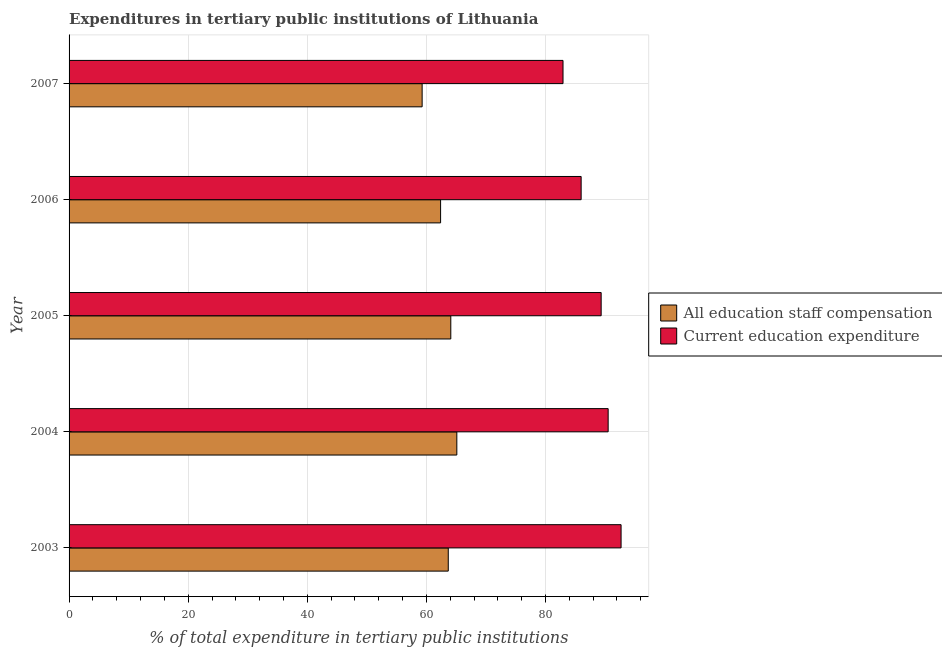How many different coloured bars are there?
Offer a terse response. 2. Are the number of bars per tick equal to the number of legend labels?
Your response must be concise. Yes. Are the number of bars on each tick of the Y-axis equal?
Your response must be concise. Yes. What is the label of the 4th group of bars from the top?
Your response must be concise. 2004. What is the expenditure in staff compensation in 2004?
Your answer should be compact. 65.11. Across all years, what is the maximum expenditure in staff compensation?
Provide a succinct answer. 65.11. Across all years, what is the minimum expenditure in staff compensation?
Keep it short and to the point. 59.29. In which year was the expenditure in staff compensation minimum?
Provide a succinct answer. 2007. What is the total expenditure in education in the graph?
Offer a very short reply. 441.48. What is the difference between the expenditure in staff compensation in 2004 and that in 2006?
Offer a terse response. 2.73. What is the difference between the expenditure in staff compensation in 2004 and the expenditure in education in 2005?
Your answer should be compact. -24.24. What is the average expenditure in staff compensation per year?
Give a very brief answer. 62.91. In the year 2007, what is the difference between the expenditure in education and expenditure in staff compensation?
Keep it short and to the point. 23.66. Is the expenditure in staff compensation in 2003 less than that in 2006?
Provide a short and direct response. No. Is the difference between the expenditure in education in 2003 and 2006 greater than the difference between the expenditure in staff compensation in 2003 and 2006?
Your response must be concise. Yes. What is the difference between the highest and the lowest expenditure in staff compensation?
Your answer should be compact. 5.82. What does the 1st bar from the top in 2006 represents?
Your answer should be compact. Current education expenditure. What does the 2nd bar from the bottom in 2006 represents?
Give a very brief answer. Current education expenditure. How many bars are there?
Your answer should be compact. 10. Does the graph contain grids?
Your answer should be compact. Yes. What is the title of the graph?
Give a very brief answer. Expenditures in tertiary public institutions of Lithuania. Does "International Tourists" appear as one of the legend labels in the graph?
Offer a terse response. No. What is the label or title of the X-axis?
Provide a short and direct response. % of total expenditure in tertiary public institutions. What is the label or title of the Y-axis?
Your answer should be compact. Year. What is the % of total expenditure in tertiary public institutions in All education staff compensation in 2003?
Your answer should be very brief. 63.67. What is the % of total expenditure in tertiary public institutions of Current education expenditure in 2003?
Give a very brief answer. 92.69. What is the % of total expenditure in tertiary public institutions of All education staff compensation in 2004?
Give a very brief answer. 65.11. What is the % of total expenditure in tertiary public institutions of Current education expenditure in 2004?
Provide a succinct answer. 90.52. What is the % of total expenditure in tertiary public institutions of All education staff compensation in 2005?
Provide a succinct answer. 64.1. What is the % of total expenditure in tertiary public institutions of Current education expenditure in 2005?
Offer a terse response. 89.35. What is the % of total expenditure in tertiary public institutions in All education staff compensation in 2006?
Ensure brevity in your answer.  62.38. What is the % of total expenditure in tertiary public institutions of Current education expenditure in 2006?
Provide a succinct answer. 85.98. What is the % of total expenditure in tertiary public institutions in All education staff compensation in 2007?
Make the answer very short. 59.29. What is the % of total expenditure in tertiary public institutions in Current education expenditure in 2007?
Your answer should be very brief. 82.94. Across all years, what is the maximum % of total expenditure in tertiary public institutions of All education staff compensation?
Ensure brevity in your answer.  65.11. Across all years, what is the maximum % of total expenditure in tertiary public institutions in Current education expenditure?
Provide a succinct answer. 92.69. Across all years, what is the minimum % of total expenditure in tertiary public institutions in All education staff compensation?
Offer a very short reply. 59.29. Across all years, what is the minimum % of total expenditure in tertiary public institutions of Current education expenditure?
Your answer should be compact. 82.94. What is the total % of total expenditure in tertiary public institutions of All education staff compensation in the graph?
Offer a terse response. 314.55. What is the total % of total expenditure in tertiary public institutions of Current education expenditure in the graph?
Your response must be concise. 441.49. What is the difference between the % of total expenditure in tertiary public institutions in All education staff compensation in 2003 and that in 2004?
Provide a succinct answer. -1.44. What is the difference between the % of total expenditure in tertiary public institutions of Current education expenditure in 2003 and that in 2004?
Provide a short and direct response. 2.17. What is the difference between the % of total expenditure in tertiary public institutions of All education staff compensation in 2003 and that in 2005?
Offer a very short reply. -0.43. What is the difference between the % of total expenditure in tertiary public institutions in Current education expenditure in 2003 and that in 2005?
Your answer should be very brief. 3.34. What is the difference between the % of total expenditure in tertiary public institutions of All education staff compensation in 2003 and that in 2006?
Offer a terse response. 1.29. What is the difference between the % of total expenditure in tertiary public institutions of Current education expenditure in 2003 and that in 2006?
Give a very brief answer. 6.71. What is the difference between the % of total expenditure in tertiary public institutions of All education staff compensation in 2003 and that in 2007?
Offer a terse response. 4.39. What is the difference between the % of total expenditure in tertiary public institutions of Current education expenditure in 2003 and that in 2007?
Offer a very short reply. 9.75. What is the difference between the % of total expenditure in tertiary public institutions in All education staff compensation in 2004 and that in 2005?
Ensure brevity in your answer.  1.01. What is the difference between the % of total expenditure in tertiary public institutions of Current education expenditure in 2004 and that in 2005?
Give a very brief answer. 1.17. What is the difference between the % of total expenditure in tertiary public institutions of All education staff compensation in 2004 and that in 2006?
Make the answer very short. 2.73. What is the difference between the % of total expenditure in tertiary public institutions in Current education expenditure in 2004 and that in 2006?
Give a very brief answer. 4.54. What is the difference between the % of total expenditure in tertiary public institutions of All education staff compensation in 2004 and that in 2007?
Provide a succinct answer. 5.82. What is the difference between the % of total expenditure in tertiary public institutions of Current education expenditure in 2004 and that in 2007?
Provide a short and direct response. 7.58. What is the difference between the % of total expenditure in tertiary public institutions of All education staff compensation in 2005 and that in 2006?
Provide a short and direct response. 1.71. What is the difference between the % of total expenditure in tertiary public institutions in Current education expenditure in 2005 and that in 2006?
Make the answer very short. 3.36. What is the difference between the % of total expenditure in tertiary public institutions in All education staff compensation in 2005 and that in 2007?
Keep it short and to the point. 4.81. What is the difference between the % of total expenditure in tertiary public institutions of Current education expenditure in 2005 and that in 2007?
Keep it short and to the point. 6.41. What is the difference between the % of total expenditure in tertiary public institutions in All education staff compensation in 2006 and that in 2007?
Make the answer very short. 3.1. What is the difference between the % of total expenditure in tertiary public institutions of Current education expenditure in 2006 and that in 2007?
Your answer should be compact. 3.04. What is the difference between the % of total expenditure in tertiary public institutions in All education staff compensation in 2003 and the % of total expenditure in tertiary public institutions in Current education expenditure in 2004?
Your answer should be very brief. -26.85. What is the difference between the % of total expenditure in tertiary public institutions of All education staff compensation in 2003 and the % of total expenditure in tertiary public institutions of Current education expenditure in 2005?
Provide a short and direct response. -25.67. What is the difference between the % of total expenditure in tertiary public institutions of All education staff compensation in 2003 and the % of total expenditure in tertiary public institutions of Current education expenditure in 2006?
Provide a short and direct response. -22.31. What is the difference between the % of total expenditure in tertiary public institutions of All education staff compensation in 2003 and the % of total expenditure in tertiary public institutions of Current education expenditure in 2007?
Ensure brevity in your answer.  -19.27. What is the difference between the % of total expenditure in tertiary public institutions in All education staff compensation in 2004 and the % of total expenditure in tertiary public institutions in Current education expenditure in 2005?
Your response must be concise. -24.24. What is the difference between the % of total expenditure in tertiary public institutions of All education staff compensation in 2004 and the % of total expenditure in tertiary public institutions of Current education expenditure in 2006?
Ensure brevity in your answer.  -20.87. What is the difference between the % of total expenditure in tertiary public institutions in All education staff compensation in 2004 and the % of total expenditure in tertiary public institutions in Current education expenditure in 2007?
Offer a terse response. -17.83. What is the difference between the % of total expenditure in tertiary public institutions of All education staff compensation in 2005 and the % of total expenditure in tertiary public institutions of Current education expenditure in 2006?
Provide a succinct answer. -21.89. What is the difference between the % of total expenditure in tertiary public institutions in All education staff compensation in 2005 and the % of total expenditure in tertiary public institutions in Current education expenditure in 2007?
Ensure brevity in your answer.  -18.84. What is the difference between the % of total expenditure in tertiary public institutions in All education staff compensation in 2006 and the % of total expenditure in tertiary public institutions in Current education expenditure in 2007?
Make the answer very short. -20.56. What is the average % of total expenditure in tertiary public institutions of All education staff compensation per year?
Offer a very short reply. 62.91. What is the average % of total expenditure in tertiary public institutions of Current education expenditure per year?
Your answer should be compact. 88.3. In the year 2003, what is the difference between the % of total expenditure in tertiary public institutions in All education staff compensation and % of total expenditure in tertiary public institutions in Current education expenditure?
Give a very brief answer. -29.02. In the year 2004, what is the difference between the % of total expenditure in tertiary public institutions in All education staff compensation and % of total expenditure in tertiary public institutions in Current education expenditure?
Offer a terse response. -25.41. In the year 2005, what is the difference between the % of total expenditure in tertiary public institutions in All education staff compensation and % of total expenditure in tertiary public institutions in Current education expenditure?
Ensure brevity in your answer.  -25.25. In the year 2006, what is the difference between the % of total expenditure in tertiary public institutions of All education staff compensation and % of total expenditure in tertiary public institutions of Current education expenditure?
Ensure brevity in your answer.  -23.6. In the year 2007, what is the difference between the % of total expenditure in tertiary public institutions of All education staff compensation and % of total expenditure in tertiary public institutions of Current education expenditure?
Your response must be concise. -23.66. What is the ratio of the % of total expenditure in tertiary public institutions in All education staff compensation in 2003 to that in 2004?
Your answer should be very brief. 0.98. What is the ratio of the % of total expenditure in tertiary public institutions of Current education expenditure in 2003 to that in 2004?
Keep it short and to the point. 1.02. What is the ratio of the % of total expenditure in tertiary public institutions of All education staff compensation in 2003 to that in 2005?
Ensure brevity in your answer.  0.99. What is the ratio of the % of total expenditure in tertiary public institutions in Current education expenditure in 2003 to that in 2005?
Offer a very short reply. 1.04. What is the ratio of the % of total expenditure in tertiary public institutions of All education staff compensation in 2003 to that in 2006?
Keep it short and to the point. 1.02. What is the ratio of the % of total expenditure in tertiary public institutions of Current education expenditure in 2003 to that in 2006?
Ensure brevity in your answer.  1.08. What is the ratio of the % of total expenditure in tertiary public institutions in All education staff compensation in 2003 to that in 2007?
Your answer should be compact. 1.07. What is the ratio of the % of total expenditure in tertiary public institutions of Current education expenditure in 2003 to that in 2007?
Provide a short and direct response. 1.12. What is the ratio of the % of total expenditure in tertiary public institutions in All education staff compensation in 2004 to that in 2005?
Provide a short and direct response. 1.02. What is the ratio of the % of total expenditure in tertiary public institutions of Current education expenditure in 2004 to that in 2005?
Give a very brief answer. 1.01. What is the ratio of the % of total expenditure in tertiary public institutions in All education staff compensation in 2004 to that in 2006?
Ensure brevity in your answer.  1.04. What is the ratio of the % of total expenditure in tertiary public institutions of Current education expenditure in 2004 to that in 2006?
Offer a terse response. 1.05. What is the ratio of the % of total expenditure in tertiary public institutions of All education staff compensation in 2004 to that in 2007?
Your answer should be very brief. 1.1. What is the ratio of the % of total expenditure in tertiary public institutions of Current education expenditure in 2004 to that in 2007?
Offer a very short reply. 1.09. What is the ratio of the % of total expenditure in tertiary public institutions of All education staff compensation in 2005 to that in 2006?
Give a very brief answer. 1.03. What is the ratio of the % of total expenditure in tertiary public institutions in Current education expenditure in 2005 to that in 2006?
Your answer should be compact. 1.04. What is the ratio of the % of total expenditure in tertiary public institutions of All education staff compensation in 2005 to that in 2007?
Provide a succinct answer. 1.08. What is the ratio of the % of total expenditure in tertiary public institutions of Current education expenditure in 2005 to that in 2007?
Your response must be concise. 1.08. What is the ratio of the % of total expenditure in tertiary public institutions in All education staff compensation in 2006 to that in 2007?
Your answer should be compact. 1.05. What is the ratio of the % of total expenditure in tertiary public institutions of Current education expenditure in 2006 to that in 2007?
Your answer should be compact. 1.04. What is the difference between the highest and the second highest % of total expenditure in tertiary public institutions of All education staff compensation?
Your answer should be very brief. 1.01. What is the difference between the highest and the second highest % of total expenditure in tertiary public institutions in Current education expenditure?
Your answer should be compact. 2.17. What is the difference between the highest and the lowest % of total expenditure in tertiary public institutions in All education staff compensation?
Make the answer very short. 5.82. What is the difference between the highest and the lowest % of total expenditure in tertiary public institutions in Current education expenditure?
Offer a terse response. 9.75. 